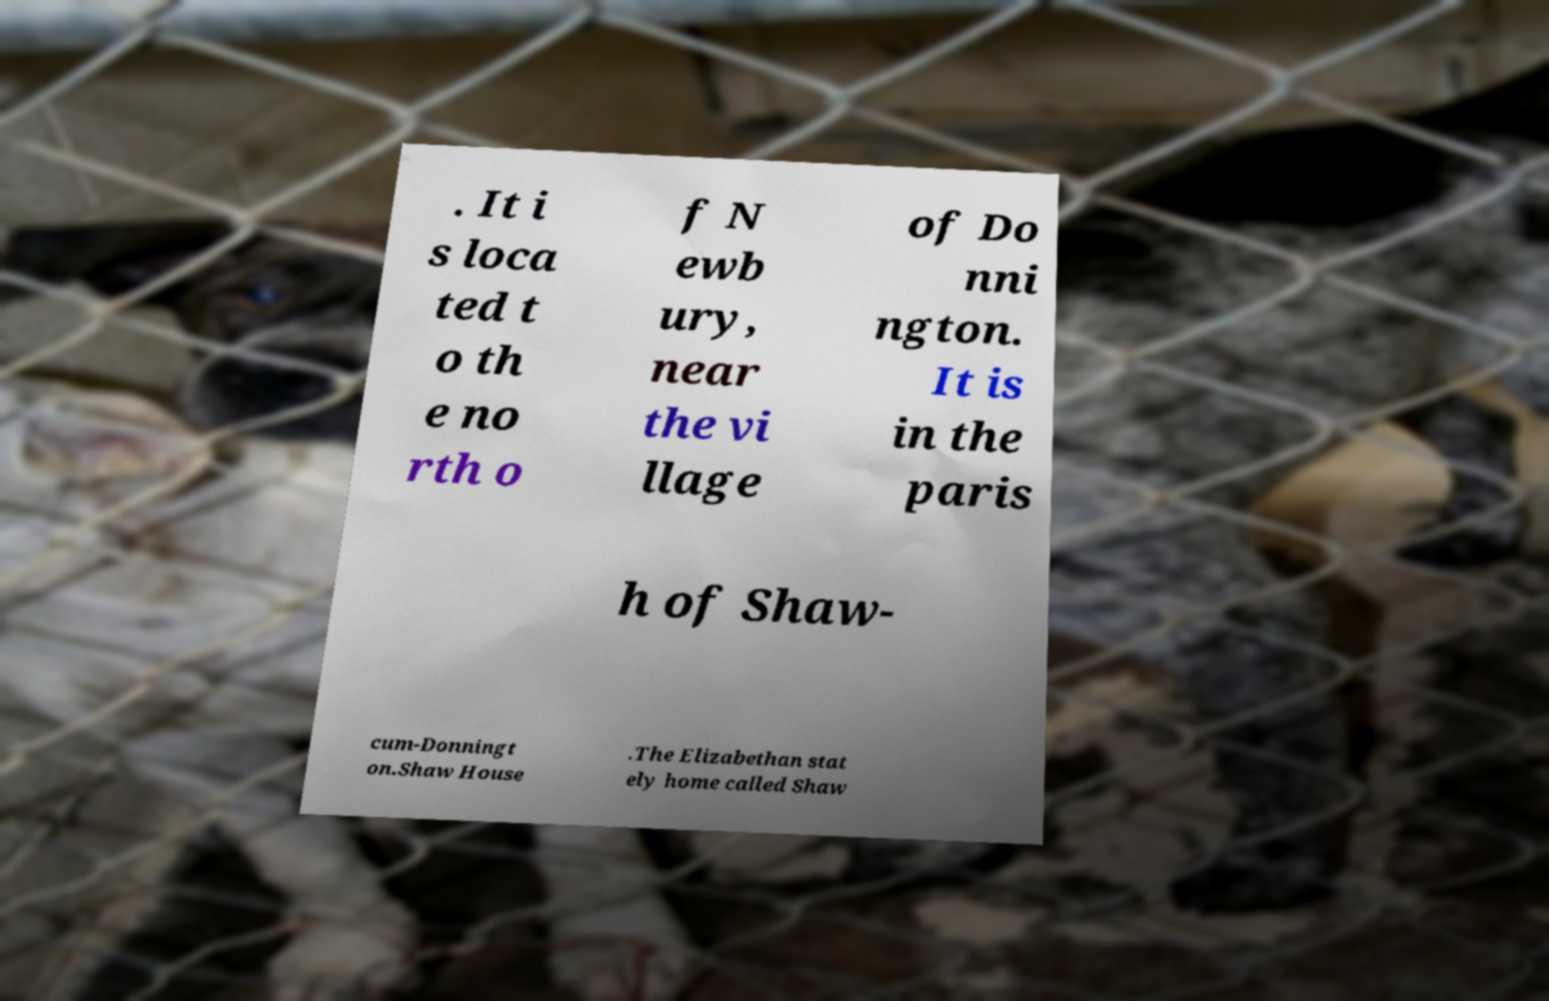Can you accurately transcribe the text from the provided image for me? . It i s loca ted t o th e no rth o f N ewb ury, near the vi llage of Do nni ngton. It is in the paris h of Shaw- cum-Donningt on.Shaw House .The Elizabethan stat ely home called Shaw 